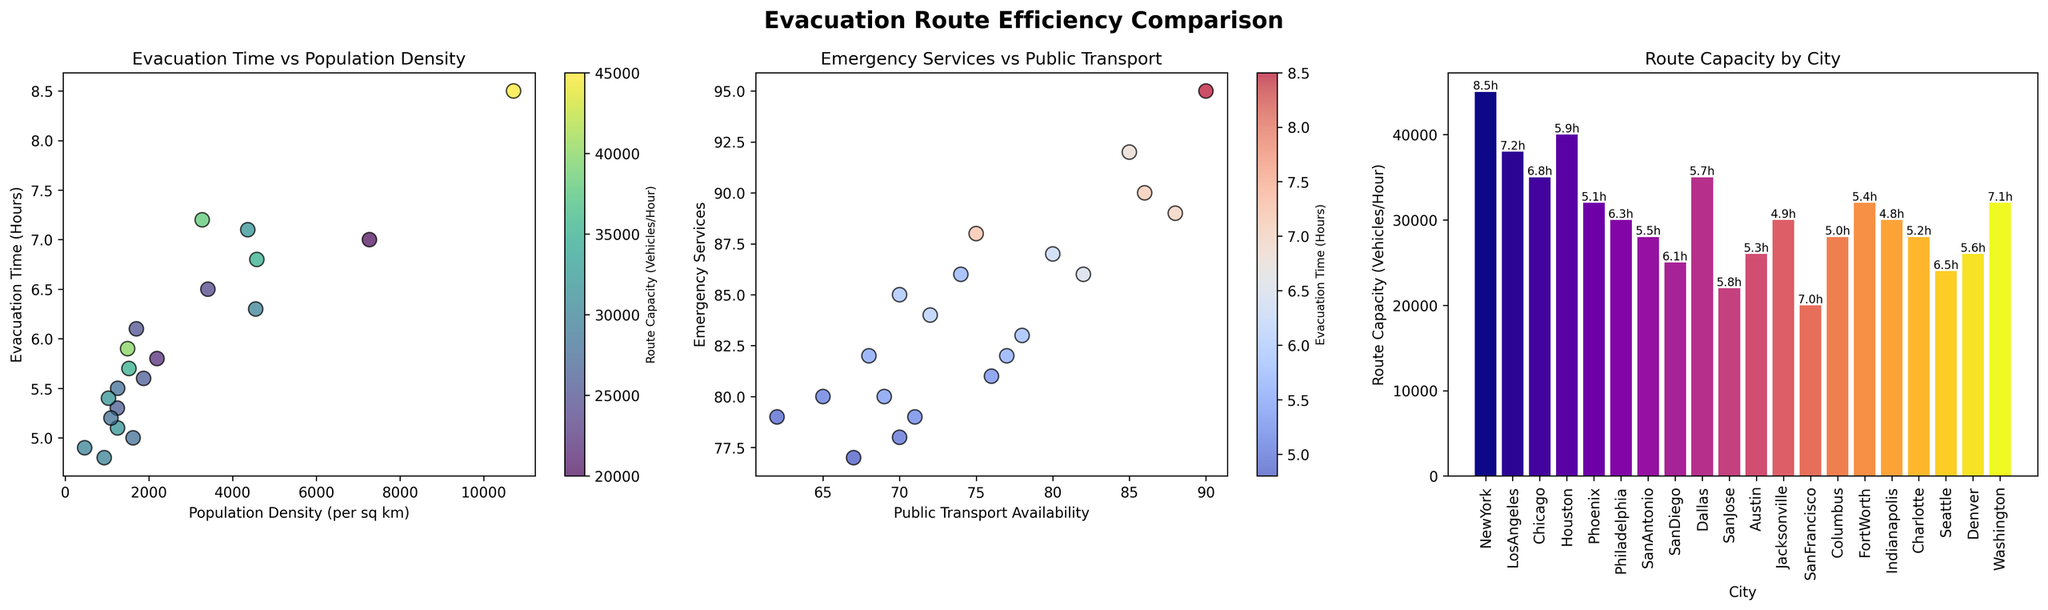Which city has the highest evacuation time? The first subplot shows the evacuation time for each city. New York has the highest point on the Evacuation Time axis.
Answer: New York In the second plot, which city has the highest combination of emergency services and public transport availability? The highest values on both the Emergency Services and Public Transport Availability axes can be seen. New York has the highest combined values.
Answer: New York What is the color representing the highest route capacity in the first subplot? The color bar indicates green represents the highest route capacity in the first subplot.
Answer: Green Which city has the highest route capacity? The third plot shows the height of the bars representing route capacity. New York has the tallest bar.
Answer: New York If we rank cities based on evacuation time, which city ranks third? The first subplot ranks cities based on their evacuation times. Chicago has the third highest evacuation time.
Answer: Chicago Compare the emergency services availability between cities with the lowest and highest evacuation times. The first subplot shows the lowest evacuation time, Jacksonville, and the highest evacuation time, New York. The second subplot shows emergency services for these cities. New York has 95, and Jacksonville has 79 for emergency services.
Answer: New York: 95, Jacksonville: 79 Between San Diego and Washington, which city has a higher evacuation time? The first subplot indicates evacuation times where Washington's point is higher than San Diego's.
Answer: Washington What is the evacuation time for the city with the median route capacity? The third subplot orders cities for route capacity. Dallas, with the median capacity, has its evacuation time labeled on the bar in the third subplot.
Answer: Dallas has 5.7 hours Which city has the lowest public transport availability? In the second subplot, the dot for Jacksonville lies on the lowest value of the Public Transport Availability axis.
Answer: Jacksonville What is the combined value of public transport availability and emergency services for Philadelphia? From the second subplot for Philadelphia: public transport availability is 80 and emergency services is 87. Summing these values, 80 + 87 = 167.
Answer: 167 